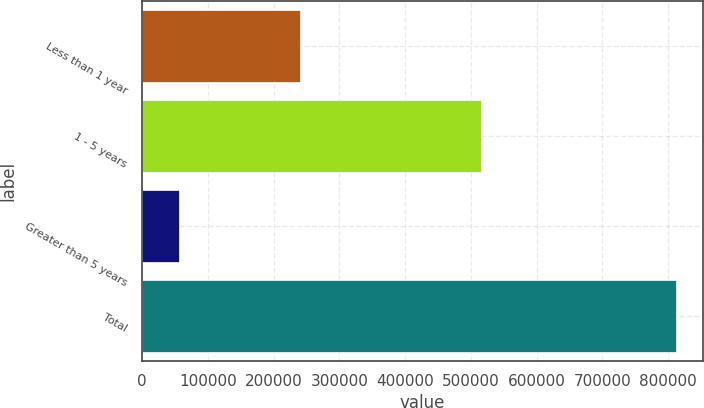Convert chart to OTSL. <chart><loc_0><loc_0><loc_500><loc_500><bar_chart><fcel>Less than 1 year<fcel>1 - 5 years<fcel>Greater than 5 years<fcel>Total<nl><fcel>240468<fcel>514986<fcel>57054<fcel>812508<nl></chart> 